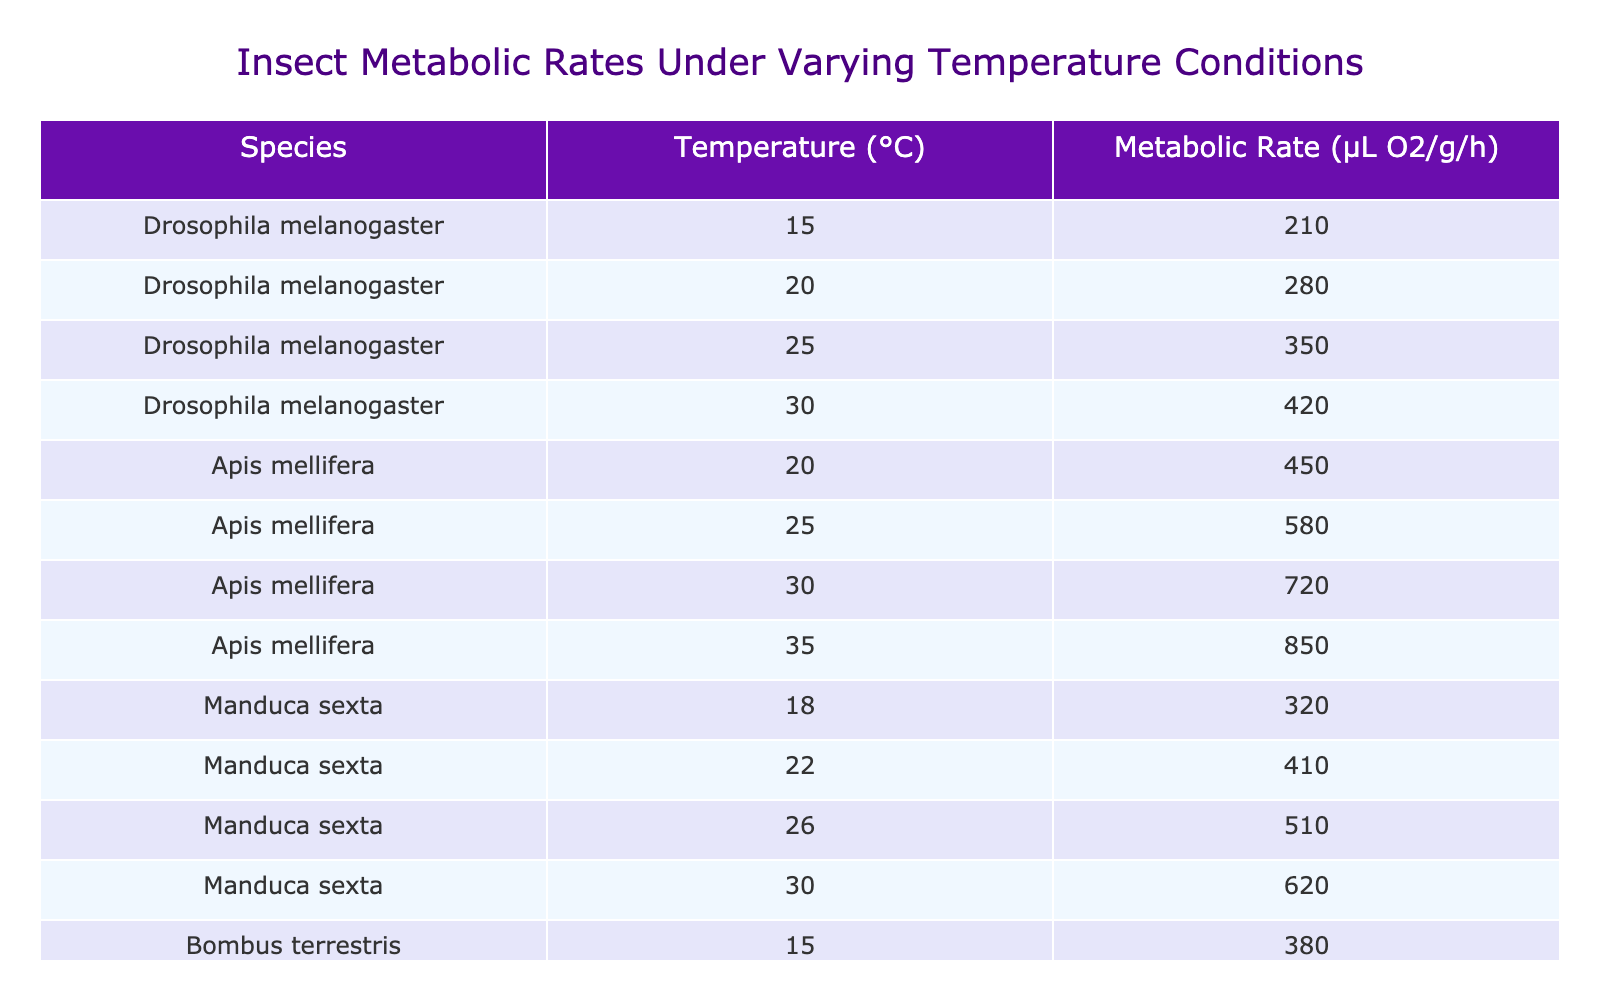What is the metabolic rate of Drosophila melanogaster at 25°C? The table indicates that for Drosophila melanogaster at 25°C, the metabolic rate is directly listed. That value is 350 µL O2/g/h.
Answer: 350 µL O2/g/h Which species has the highest metabolic rate at 30°C? By examining the table for the metabolic rates at 30°C, we identify the values for each species at this temperature: Drosophila melanogaster has 420 µL O2/g/h, Apis mellifera has 720 µL O2/g/h, Manduca sexta has 620 µL O2/g/h, and Bombus terrestris has 760 µL O2/g/h. The highest value is from Bombus terrestris at 760 µL O2/g/h.
Answer: Bombus terrestris What is the average metabolic rate of Apis mellifera across the recorded temperatures? The temperatures for Apis mellifera are 20°C, 25°C, 30°C, and 35°C with associated metabolic rates of 450, 580, 720, and 850 µL O2/g/h respectively. To find the average: (450 + 580 + 720 + 850) = 2600, and then divide by the number of observations, which is 4. So, 2600 / 4 = 650 µL O2/g/h.
Answer: 650 µL O2/g/h Is the metabolic rate for Manduca sexta at 30°C greater than that of Drosophila melanogaster at the same temperature? Looking at the table, Manduca sexta has a metabolic rate of 620 µL O2/g/h at 30°C, while Drosophila melanogaster has a lower metabolic rate of 420 µL O2/g/h at the same temperature. Therefore, the statement is true.
Answer: Yes If we compare the metabolic rates of Bombus terrestris at 15°C and 25°C, what is the difference? From the data, Bombus terrestris has a metabolic rate of 380 µL O2/g/h at 15°C and 620 µL O2/g/h at 25°C. To find the difference, we subtract: 620 - 380 = 240 µL O2/g/h.
Answer: 240 µL O2/g/h What temperature has the steepest increase in metabolic rate for Apis mellifera from one measurement to the next? Analyzing the metabolic rates of Apis mellifera: from 20°C to 25°C, the increase is (580 - 450) = 130 µL O2/g/h, and from 25°C to 30°C, the increase is (720 - 580) = 140 µL O2/g/h, and from 30°C to 35°C, the increase is (850 - 720) = 130 µL O2/g/h. Therefore, the steepest increase is between 25°C and 30°C by 140 µL O2/g/h.
Answer: 25°C to 30°C Which insect shows an increase in metabolic rate with every increase in temperature? By reviewing the metabolic rates provided, every species has shown an increase in metabolic rate as the temperature rises: Drosophila melanogaster, Apis mellifera, Manduca sexta, and Bombus terrestris. Thus, the answer would be yes, all species show this trend.
Answer: Yes 